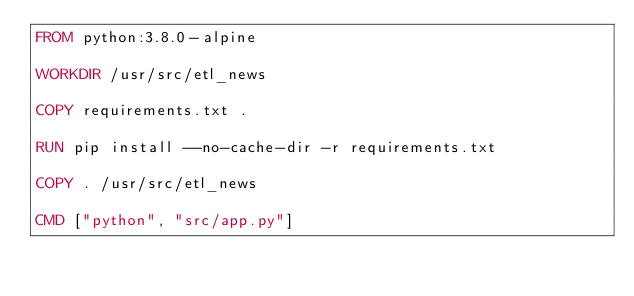Convert code to text. <code><loc_0><loc_0><loc_500><loc_500><_Dockerfile_>FROM python:3.8.0-alpine

WORKDIR /usr/src/etl_news

COPY requirements.txt .

RUN pip install --no-cache-dir -r requirements.txt

COPY . /usr/src/etl_news

CMD ["python", "src/app.py"]

</code> 